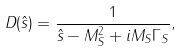Convert formula to latex. <formula><loc_0><loc_0><loc_500><loc_500>D ( { \hat { s } } ) = \frac { 1 } { { \hat { s } } - M _ { S } ^ { 2 } + i M _ { S } \Gamma _ { S } } ,</formula> 